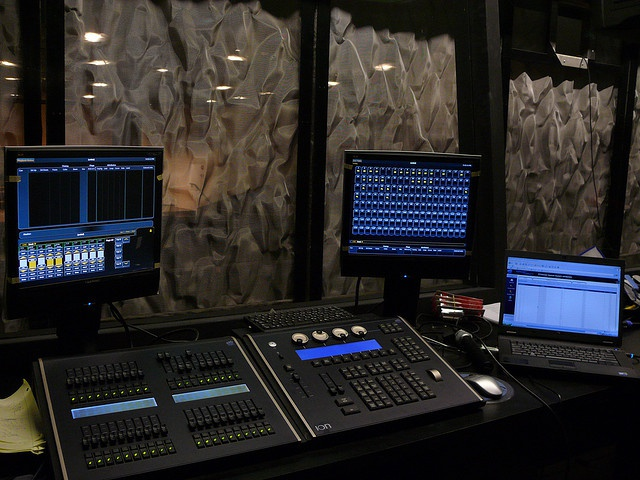Describe the objects in this image and their specific colors. I can see tv in black, navy, and blue tones, tv in black, navy, and blue tones, laptop in black, lightblue, blue, and navy tones, and mouse in black, white, gray, and darkgray tones in this image. 